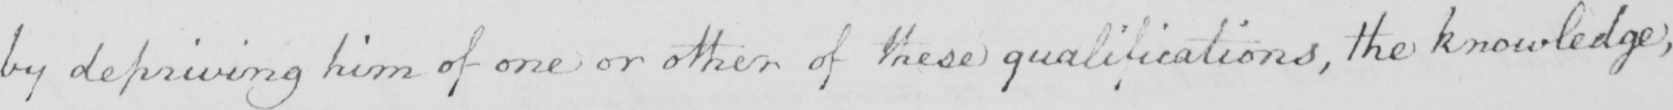Can you read and transcribe this handwriting? by depriving him of one or other of these qualifications , the knowledge ; 